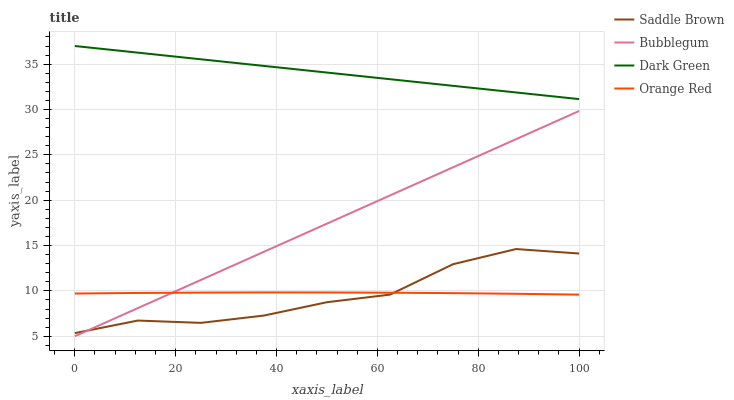Does Bubblegum have the minimum area under the curve?
Answer yes or no. No. Does Bubblegum have the maximum area under the curve?
Answer yes or no. No. Is Saddle Brown the smoothest?
Answer yes or no. No. Is Bubblegum the roughest?
Answer yes or no. No. Does Saddle Brown have the lowest value?
Answer yes or no. No. Does Saddle Brown have the highest value?
Answer yes or no. No. Is Orange Red less than Dark Green?
Answer yes or no. Yes. Is Dark Green greater than Orange Red?
Answer yes or no. Yes. Does Orange Red intersect Dark Green?
Answer yes or no. No. 